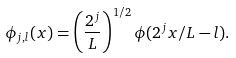Convert formula to latex. <formula><loc_0><loc_0><loc_500><loc_500>\phi _ { j , l } ( x ) = \left ( \frac { 2 ^ { j } } { L } \right ) ^ { 1 / 2 } \phi ( 2 ^ { j } x / L - l ) .</formula> 